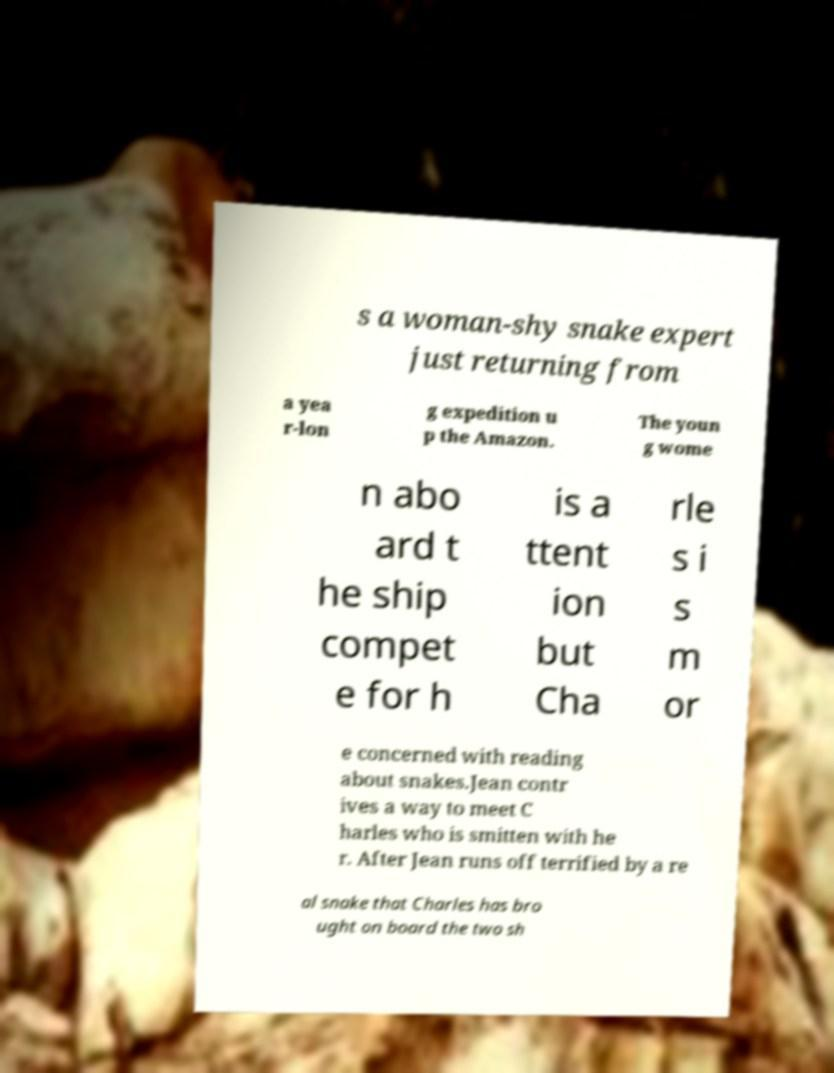For documentation purposes, I need the text within this image transcribed. Could you provide that? s a woman-shy snake expert just returning from a yea r-lon g expedition u p the Amazon. The youn g wome n abo ard t he ship compet e for h is a ttent ion but Cha rle s i s m or e concerned with reading about snakes.Jean contr ives a way to meet C harles who is smitten with he r. After Jean runs off terrified by a re al snake that Charles has bro ught on board the two sh 